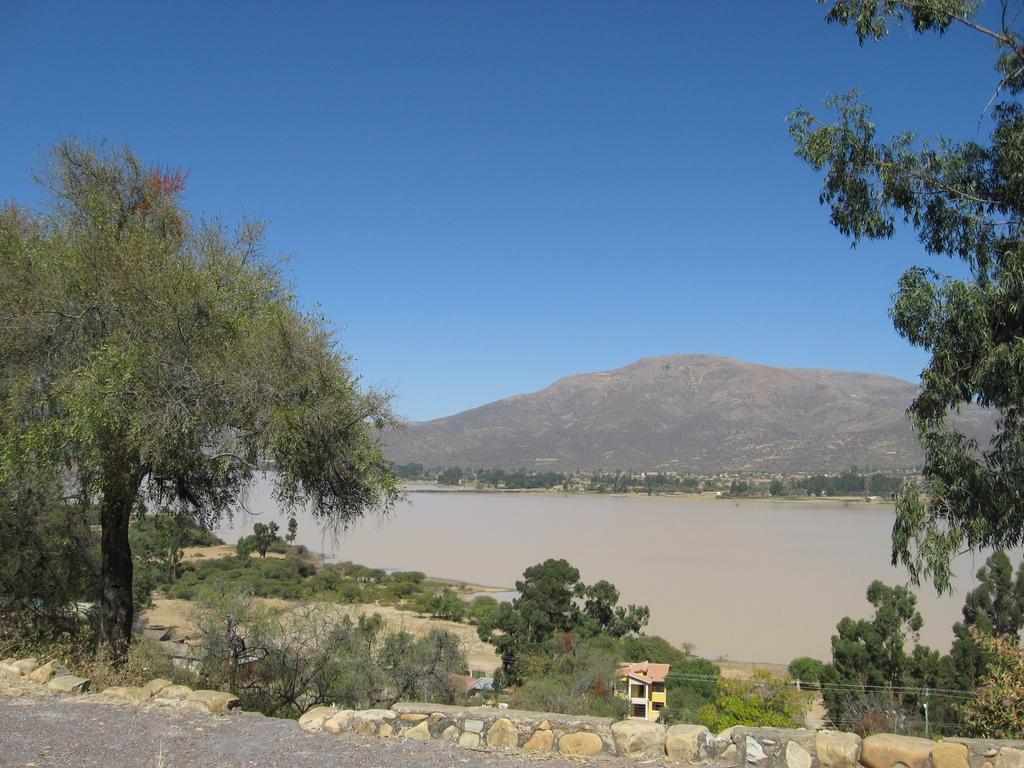Please provide a concise description of this image. In the center of the image there is water. There are buildings, trees, electrical poles with cables. In the background of the image there are mountains. At the top of the image there is sky. 